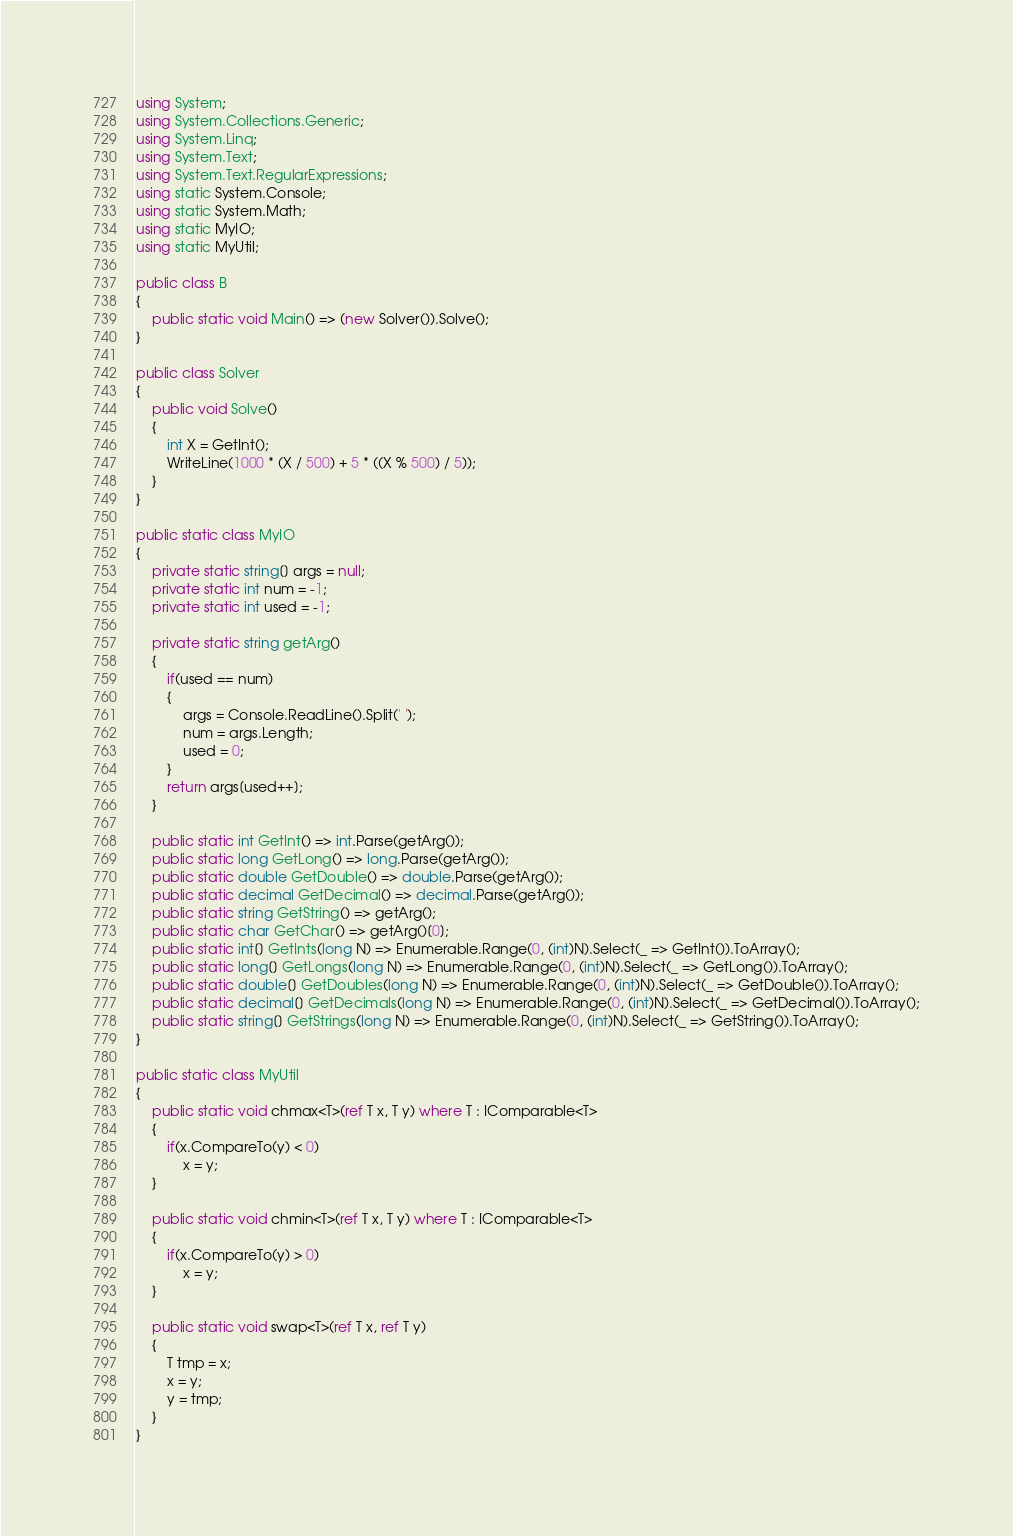<code> <loc_0><loc_0><loc_500><loc_500><_C#_>using System;
using System.Collections.Generic;
using System.Linq;
using System.Text;
using System.Text.RegularExpressions;
using static System.Console;
using static System.Math;
using static MyIO;
using static MyUtil;

public class B
{
	public static void Main() => (new Solver()).Solve();
}

public class Solver
{
	public void Solve()
	{
		int X = GetInt();
		WriteLine(1000 * (X / 500) + 5 * ((X % 500) / 5));
	}
}

public static class MyIO
{
	private static string[] args = null;
	private static int num = -1;
	private static int used = -1;

	private static string getArg()
	{
		if(used == num)
		{
			args = Console.ReadLine().Split(' ');
			num = args.Length;
			used = 0;
		}
		return args[used++];
	}

	public static int GetInt() => int.Parse(getArg());
	public static long GetLong() => long.Parse(getArg());
	public static double GetDouble() => double.Parse(getArg());
	public static decimal GetDecimal() => decimal.Parse(getArg());
	public static string GetString() => getArg();
	public static char GetChar() => getArg()[0];
	public static int[] GetInts(long N) => Enumerable.Range(0, (int)N).Select(_ => GetInt()).ToArray();
	public static long[] GetLongs(long N) => Enumerable.Range(0, (int)N).Select(_ => GetLong()).ToArray();
	public static double[] GetDoubles(long N) => Enumerable.Range(0, (int)N).Select(_ => GetDouble()).ToArray();
	public static decimal[] GetDecimals(long N) => Enumerable.Range(0, (int)N).Select(_ => GetDecimal()).ToArray();
	public static string[] GetStrings(long N) => Enumerable.Range(0, (int)N).Select(_ => GetString()).ToArray();
}

public static class MyUtil
{
	public static void chmax<T>(ref T x, T y) where T : IComparable<T>
	{
		if(x.CompareTo(y) < 0)
			x = y;
	}

	public static void chmin<T>(ref T x, T y) where T : IComparable<T>
	{
		if(x.CompareTo(y) > 0)
			x = y;
	}

	public static void swap<T>(ref T x, ref T y)
	{
		T tmp = x;
		x = y;
		y = tmp;
	}
}</code> 